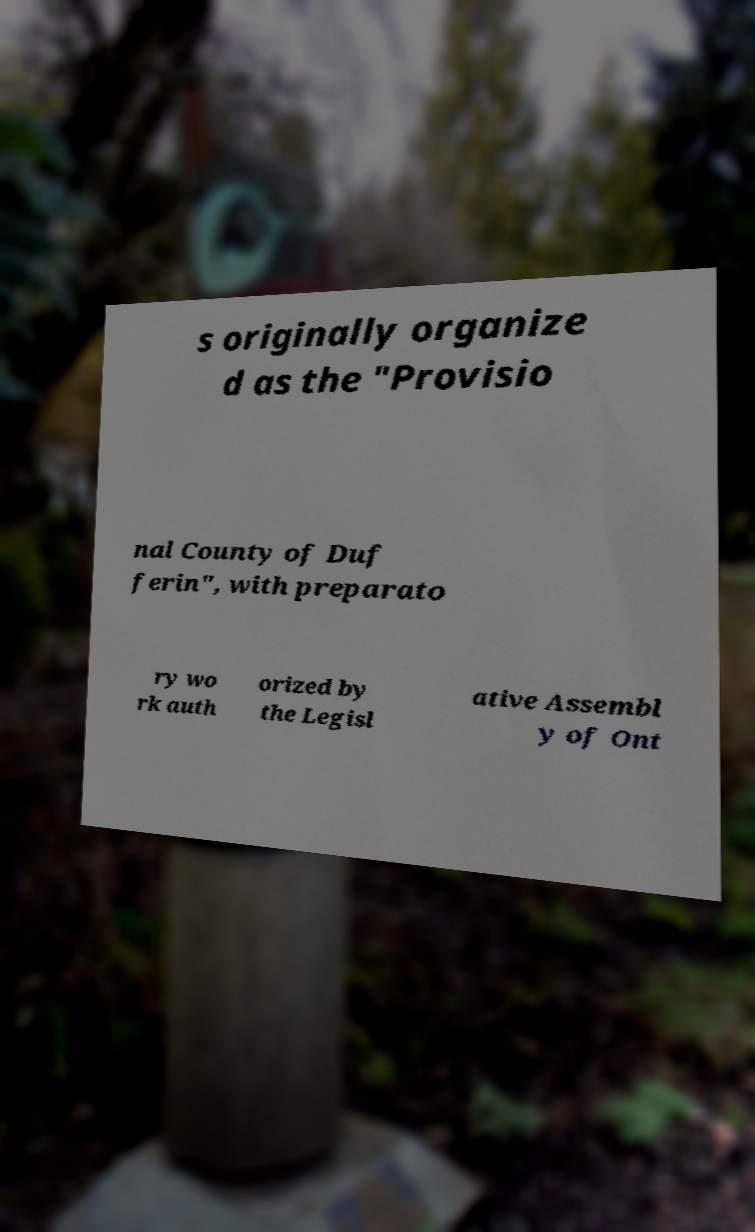Please identify and transcribe the text found in this image. s originally organize d as the "Provisio nal County of Duf ferin", with preparato ry wo rk auth orized by the Legisl ative Assembl y of Ont 